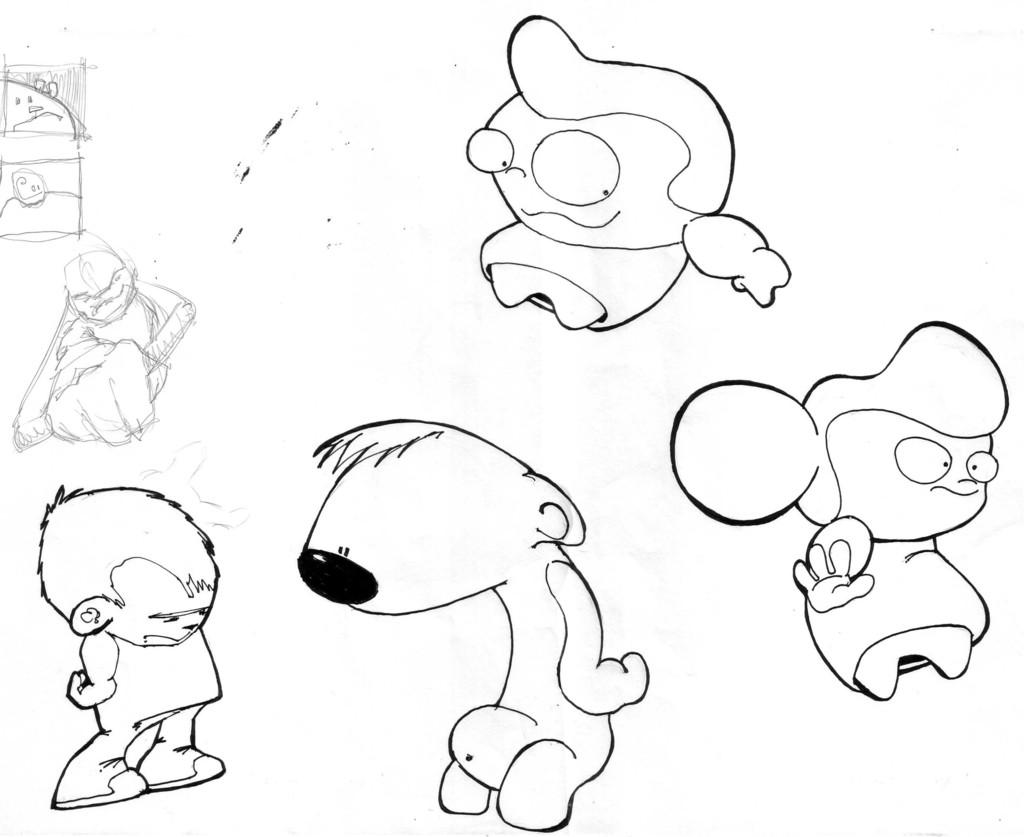What type of art is shown in the image? The image is a pencil art. What animals or creatures are depicted in the art? There is a dog depicted in the art. What human subjects are shown in the art? There is a boy and two girls depicted in the art. What type of skirt is the toad wearing in the image? There is no toad present in the image, and therefore no skirt to describe. 